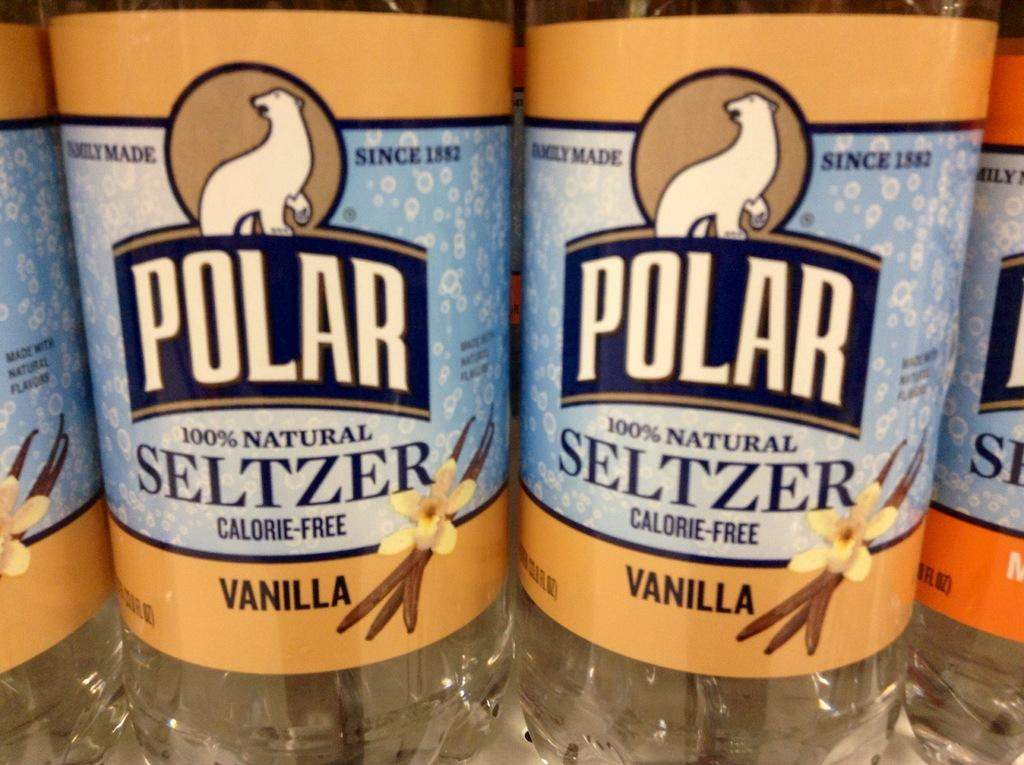<image>
Summarize the visual content of the image. close up of Polar 100% natural Seltzer Vanilla flavor 